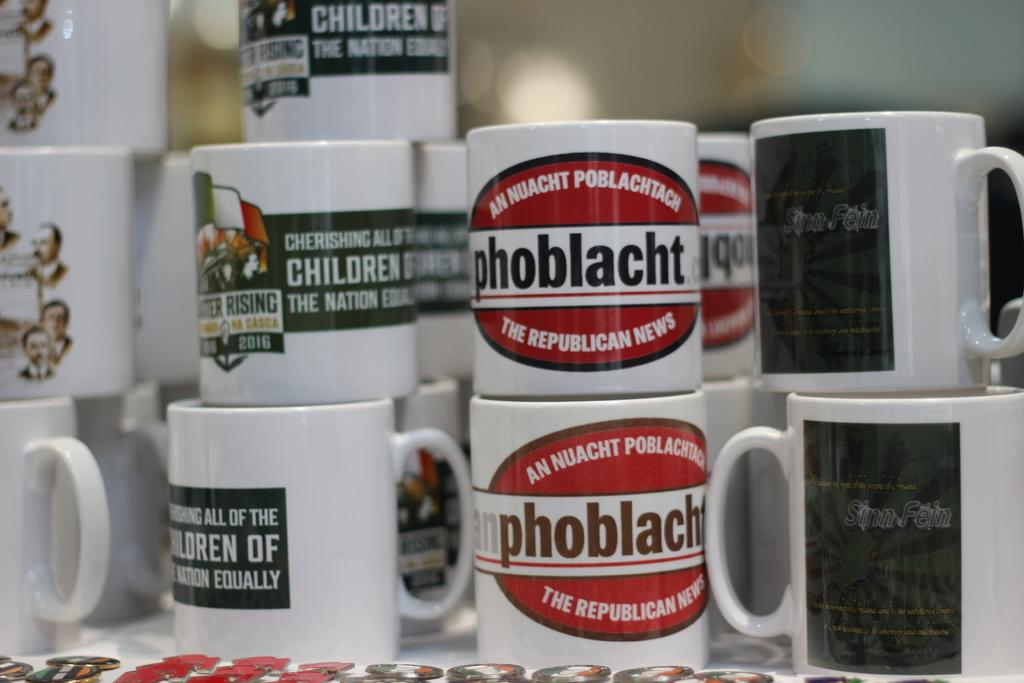<image>
Render a clear and concise summary of the photo. Many different mugs are stacked up, several of which have phoblacht printed on it. 